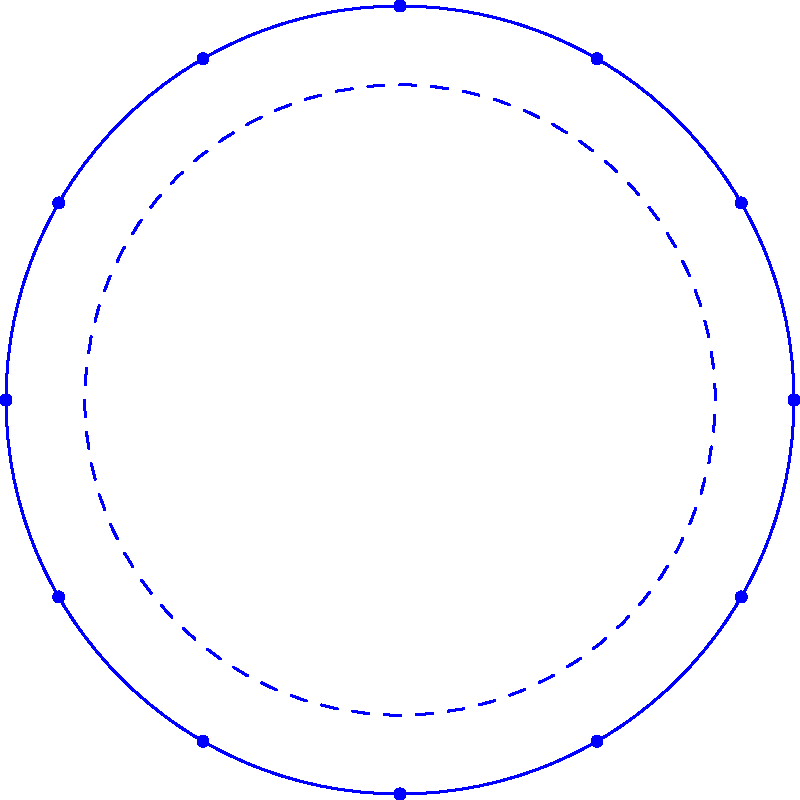In the EU flag, 12 stars are arranged in a circle. If the angle between any two adjacent stars is $\theta$, and the sum of all these angles is 360°, what is the value of $\theta$? To solve this problem, let's follow these steps:

1) First, we need to understand that the stars form a regular dodecagon (12-sided polygon).

2) In a circle, the sum of all angles at the center is 360°.

3) We are told that the sum of all angles between adjacent stars is also 360°.

4) This means that each angle $\theta$ between adjacent stars is equal to the central angle formed by those stars.

5) Since there are 12 stars, and the total angle is 360°, we can set up an equation:

   $12\theta = 360°$

6) Solving for $\theta$:

   $\theta = 360° \div 12 = 30°$

Therefore, the angle between any two adjacent stars is 30°.
Answer: 30° 